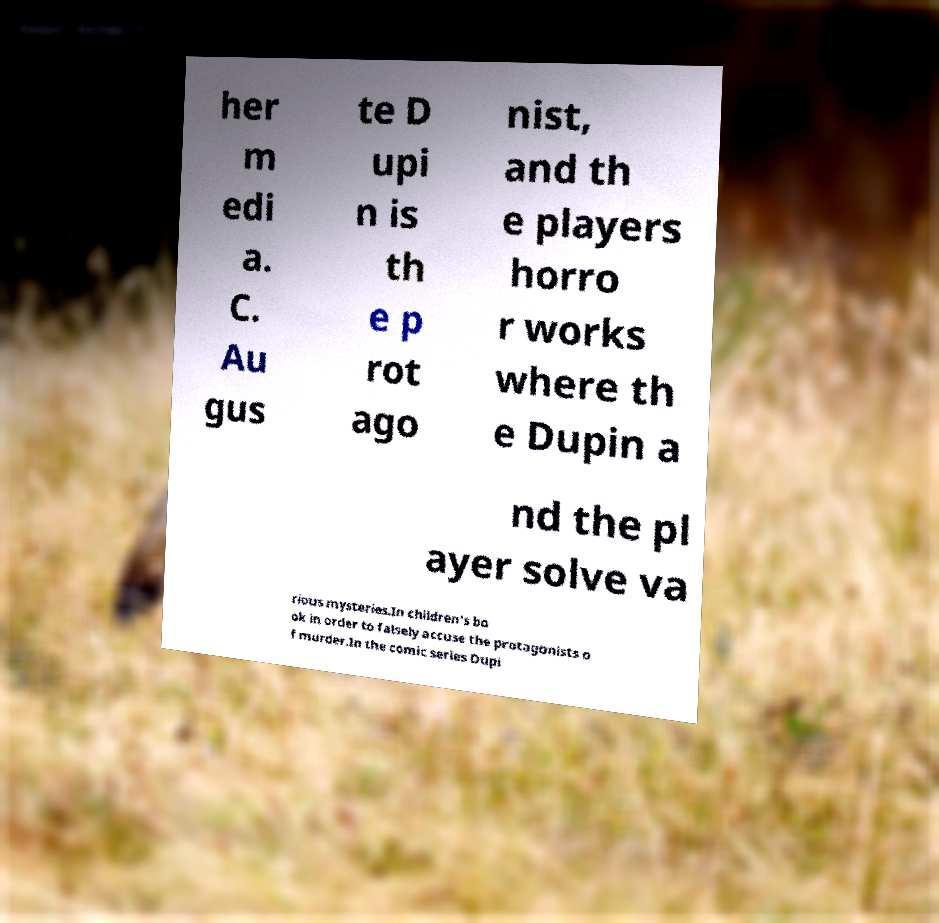Can you read and provide the text displayed in the image?This photo seems to have some interesting text. Can you extract and type it out for me? her m edi a. C. Au gus te D upi n is th e p rot ago nist, and th e players horro r works where th e Dupin a nd the pl ayer solve va rious mysteries.In children's bo ok in order to falsely accuse the protagonists o f murder.In the comic series Dupi 